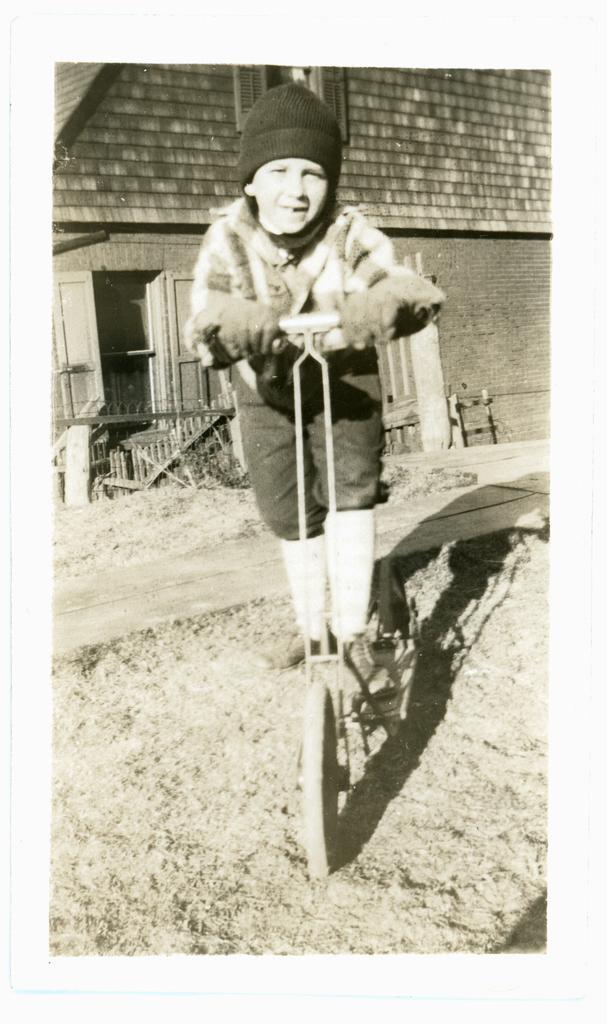In one or two sentences, can you explain what this image depicts? In the foreground I can see a boy is riding a vehicle on the road. In the background I can see a building, door, fence and so on. This image is taken may be during a day. 